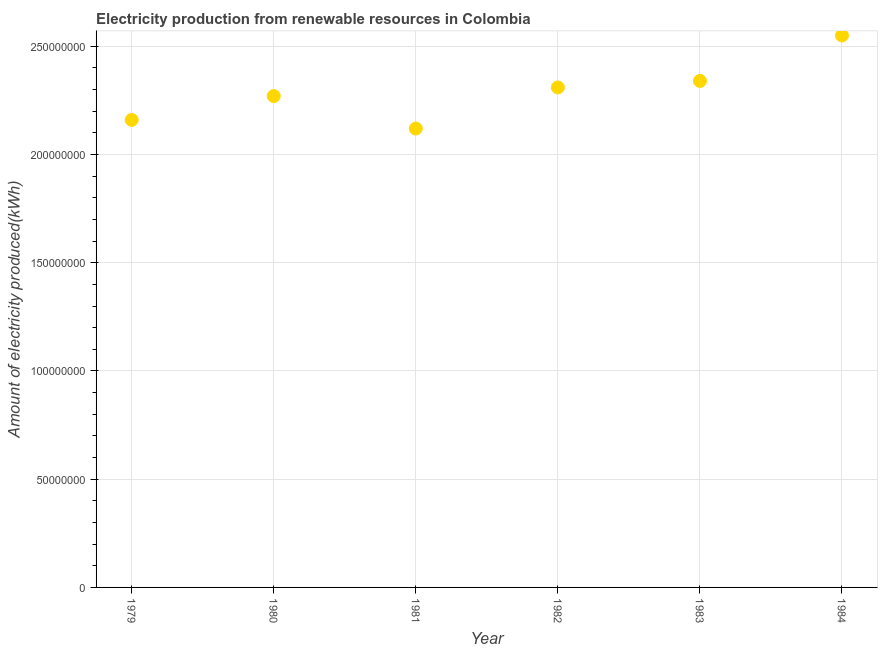What is the amount of electricity produced in 1980?
Offer a terse response. 2.27e+08. Across all years, what is the maximum amount of electricity produced?
Your answer should be compact. 2.55e+08. Across all years, what is the minimum amount of electricity produced?
Provide a succinct answer. 2.12e+08. What is the sum of the amount of electricity produced?
Your answer should be very brief. 1.38e+09. What is the difference between the amount of electricity produced in 1980 and 1981?
Offer a very short reply. 1.50e+07. What is the average amount of electricity produced per year?
Offer a terse response. 2.29e+08. What is the median amount of electricity produced?
Provide a short and direct response. 2.29e+08. Do a majority of the years between 1984 and 1979 (inclusive) have amount of electricity produced greater than 80000000 kWh?
Provide a succinct answer. Yes. What is the ratio of the amount of electricity produced in 1981 to that in 1984?
Your answer should be very brief. 0.83. What is the difference between the highest and the second highest amount of electricity produced?
Your answer should be very brief. 2.10e+07. What is the difference between the highest and the lowest amount of electricity produced?
Offer a terse response. 4.30e+07. In how many years, is the amount of electricity produced greater than the average amount of electricity produced taken over all years?
Your answer should be very brief. 3. How many dotlines are there?
Ensure brevity in your answer.  1. Are the values on the major ticks of Y-axis written in scientific E-notation?
Offer a very short reply. No. Does the graph contain any zero values?
Your answer should be compact. No. Does the graph contain grids?
Your response must be concise. Yes. What is the title of the graph?
Provide a short and direct response. Electricity production from renewable resources in Colombia. What is the label or title of the Y-axis?
Your answer should be compact. Amount of electricity produced(kWh). What is the Amount of electricity produced(kWh) in 1979?
Offer a very short reply. 2.16e+08. What is the Amount of electricity produced(kWh) in 1980?
Ensure brevity in your answer.  2.27e+08. What is the Amount of electricity produced(kWh) in 1981?
Your response must be concise. 2.12e+08. What is the Amount of electricity produced(kWh) in 1982?
Offer a very short reply. 2.31e+08. What is the Amount of electricity produced(kWh) in 1983?
Your response must be concise. 2.34e+08. What is the Amount of electricity produced(kWh) in 1984?
Make the answer very short. 2.55e+08. What is the difference between the Amount of electricity produced(kWh) in 1979 and 1980?
Give a very brief answer. -1.10e+07. What is the difference between the Amount of electricity produced(kWh) in 1979 and 1982?
Provide a succinct answer. -1.50e+07. What is the difference between the Amount of electricity produced(kWh) in 1979 and 1983?
Ensure brevity in your answer.  -1.80e+07. What is the difference between the Amount of electricity produced(kWh) in 1979 and 1984?
Give a very brief answer. -3.90e+07. What is the difference between the Amount of electricity produced(kWh) in 1980 and 1981?
Keep it short and to the point. 1.50e+07. What is the difference between the Amount of electricity produced(kWh) in 1980 and 1983?
Your answer should be compact. -7.00e+06. What is the difference between the Amount of electricity produced(kWh) in 1980 and 1984?
Ensure brevity in your answer.  -2.80e+07. What is the difference between the Amount of electricity produced(kWh) in 1981 and 1982?
Provide a succinct answer. -1.90e+07. What is the difference between the Amount of electricity produced(kWh) in 1981 and 1983?
Offer a very short reply. -2.20e+07. What is the difference between the Amount of electricity produced(kWh) in 1981 and 1984?
Your answer should be very brief. -4.30e+07. What is the difference between the Amount of electricity produced(kWh) in 1982 and 1983?
Offer a very short reply. -3.00e+06. What is the difference between the Amount of electricity produced(kWh) in 1982 and 1984?
Offer a very short reply. -2.40e+07. What is the difference between the Amount of electricity produced(kWh) in 1983 and 1984?
Provide a short and direct response. -2.10e+07. What is the ratio of the Amount of electricity produced(kWh) in 1979 to that in 1982?
Offer a very short reply. 0.94. What is the ratio of the Amount of electricity produced(kWh) in 1979 to that in 1983?
Offer a very short reply. 0.92. What is the ratio of the Amount of electricity produced(kWh) in 1979 to that in 1984?
Make the answer very short. 0.85. What is the ratio of the Amount of electricity produced(kWh) in 1980 to that in 1981?
Your answer should be very brief. 1.07. What is the ratio of the Amount of electricity produced(kWh) in 1980 to that in 1984?
Provide a short and direct response. 0.89. What is the ratio of the Amount of electricity produced(kWh) in 1981 to that in 1982?
Make the answer very short. 0.92. What is the ratio of the Amount of electricity produced(kWh) in 1981 to that in 1983?
Your answer should be compact. 0.91. What is the ratio of the Amount of electricity produced(kWh) in 1981 to that in 1984?
Your answer should be very brief. 0.83. What is the ratio of the Amount of electricity produced(kWh) in 1982 to that in 1984?
Offer a very short reply. 0.91. What is the ratio of the Amount of electricity produced(kWh) in 1983 to that in 1984?
Your answer should be compact. 0.92. 